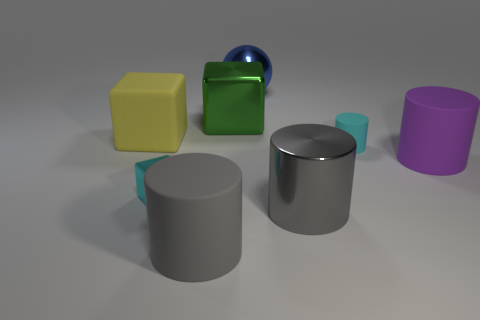Subtract all blue cylinders. Subtract all red cubes. How many cylinders are left? 4 Add 1 gray metal things. How many objects exist? 9 Subtract all cubes. How many objects are left? 5 Add 5 green objects. How many green objects exist? 6 Subtract 0 yellow cylinders. How many objects are left? 8 Subtract all big green rubber blocks. Subtract all blue metal balls. How many objects are left? 7 Add 4 large green blocks. How many large green blocks are left? 5 